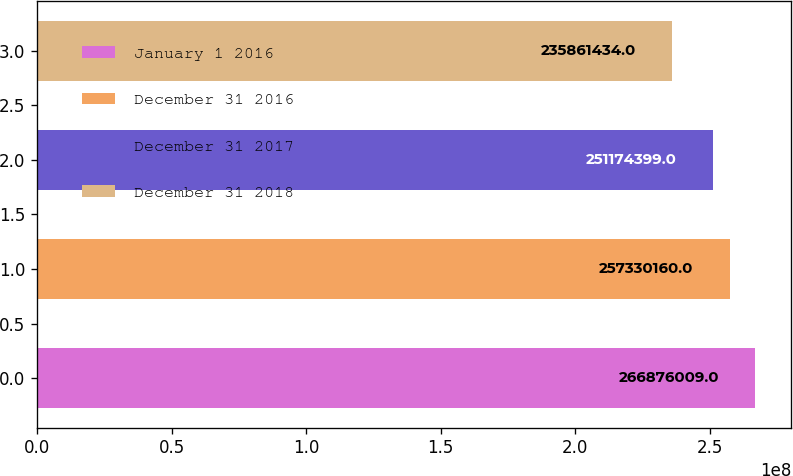<chart> <loc_0><loc_0><loc_500><loc_500><bar_chart><fcel>January 1 2016<fcel>December 31 2016<fcel>December 31 2017<fcel>December 31 2018<nl><fcel>2.66876e+08<fcel>2.5733e+08<fcel>2.51174e+08<fcel>2.35861e+08<nl></chart> 